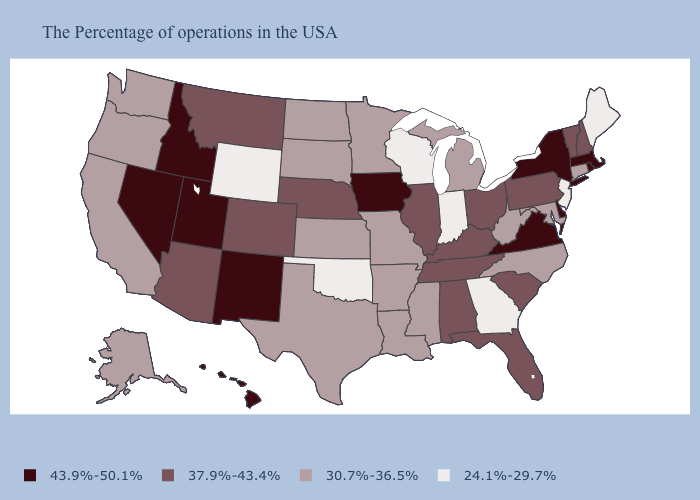What is the value of Alaska?
Write a very short answer. 30.7%-36.5%. Does Alabama have a lower value than Utah?
Answer briefly. Yes. Is the legend a continuous bar?
Concise answer only. No. Which states have the lowest value in the USA?
Be succinct. Maine, New Jersey, Georgia, Indiana, Wisconsin, Oklahoma, Wyoming. What is the value of Alaska?
Give a very brief answer. 30.7%-36.5%. What is the value of Wyoming?
Short answer required. 24.1%-29.7%. Name the states that have a value in the range 24.1%-29.7%?
Concise answer only. Maine, New Jersey, Georgia, Indiana, Wisconsin, Oklahoma, Wyoming. What is the value of Illinois?
Quick response, please. 37.9%-43.4%. Name the states that have a value in the range 24.1%-29.7%?
Concise answer only. Maine, New Jersey, Georgia, Indiana, Wisconsin, Oklahoma, Wyoming. What is the lowest value in the South?
Give a very brief answer. 24.1%-29.7%. What is the highest value in the USA?
Quick response, please. 43.9%-50.1%. What is the value of Washington?
Be succinct. 30.7%-36.5%. What is the value of Kansas?
Be succinct. 30.7%-36.5%. What is the value of New Mexico?
Short answer required. 43.9%-50.1%. 